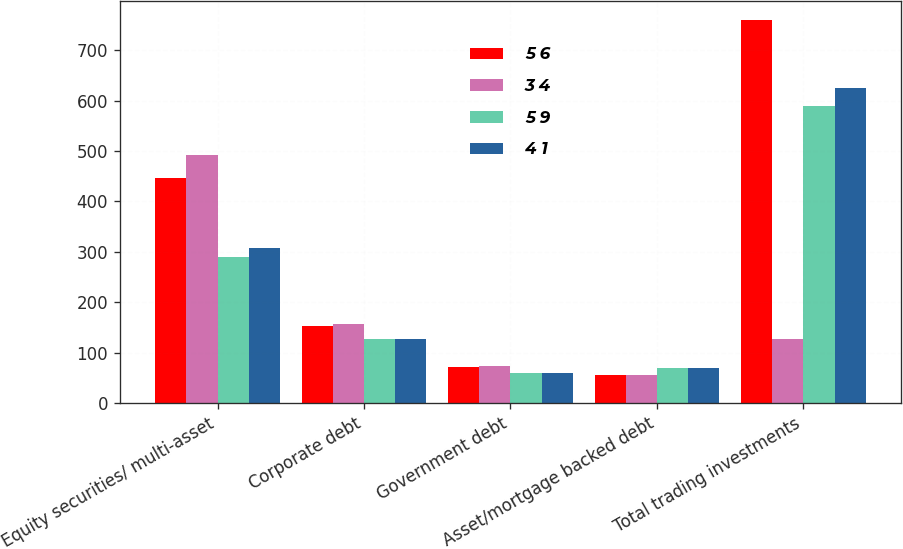Convert chart. <chart><loc_0><loc_0><loc_500><loc_500><stacked_bar_chart><ecel><fcel>Equity securities/ multi-asset<fcel>Corporate debt<fcel>Government debt<fcel>Asset/mortgage backed debt<fcel>Total trading investments<nl><fcel>5 6<fcel>446<fcel>152<fcel>72<fcel>56<fcel>760<nl><fcel>3 4<fcel>493<fcel>157<fcel>73<fcel>56<fcel>128<nl><fcel>5 9<fcel>290<fcel>128<fcel>60<fcel>70<fcel>589<nl><fcel>4 1<fcel>308<fcel>128<fcel>60<fcel>70<fcel>625<nl></chart> 